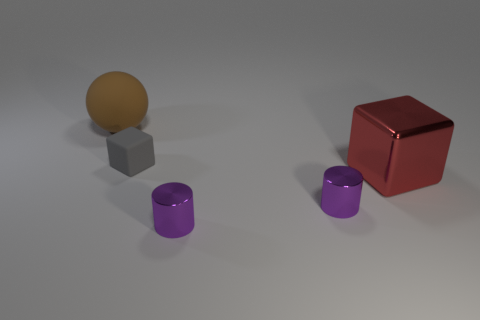Is the big shiny thing the same color as the big rubber thing?
Your response must be concise. No. There is a block that is on the left side of the large thing in front of the big rubber ball; what is its size?
Your answer should be very brief. Small. Is the tiny thing behind the metal block made of the same material as the big object on the left side of the large metallic cube?
Your answer should be very brief. Yes. Is the color of the large object that is to the right of the brown thing the same as the tiny rubber object?
Make the answer very short. No. There is a tiny gray thing; what number of gray rubber objects are behind it?
Make the answer very short. 0. Does the large cube have the same material as the cube behind the red object?
Provide a succinct answer. No. What size is the brown ball that is made of the same material as the tiny cube?
Provide a short and direct response. Large. Is the number of rubber objects that are to the left of the large brown object greater than the number of objects that are to the left of the gray block?
Your answer should be very brief. No. Are there any other purple shiny things that have the same shape as the big metallic object?
Provide a short and direct response. No. There is a cube in front of the matte cube; does it have the same size as the large brown ball?
Make the answer very short. Yes. 